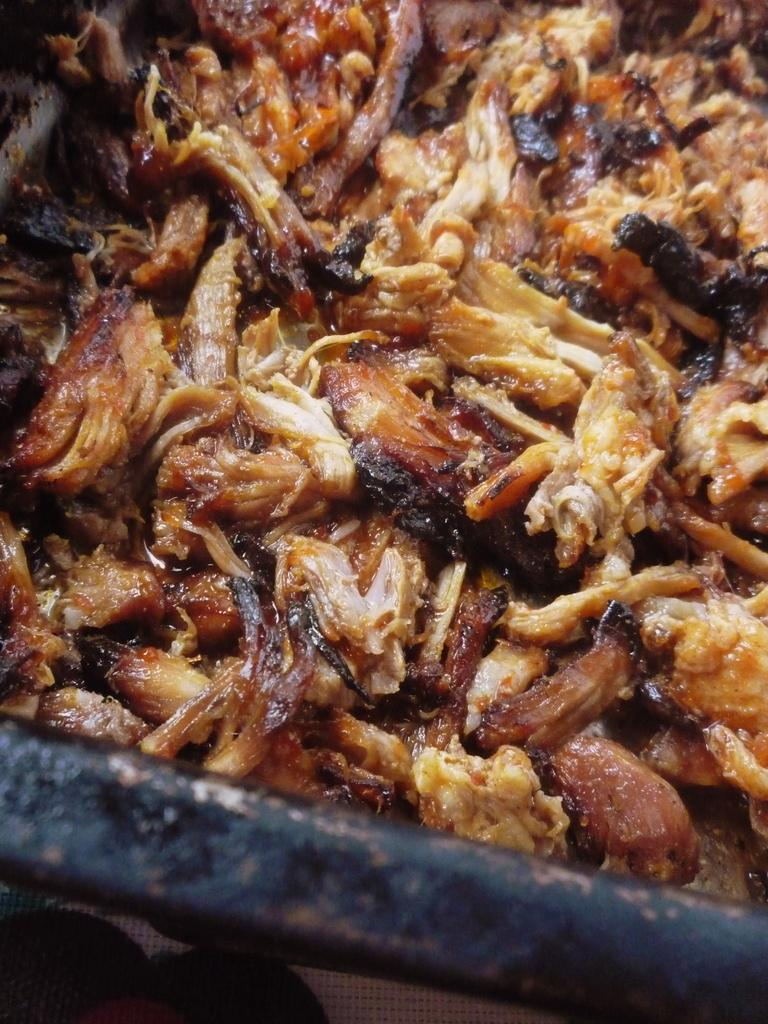What is the main object in the image that resembles a pan? There is an object in the image that resembles a pan. What is inside the pan-like object? There are food items in the pan-like object. What type of engine can be seen powering the food items in the image? There is no engine present in the image, and the food items are not being powered by any engine. 